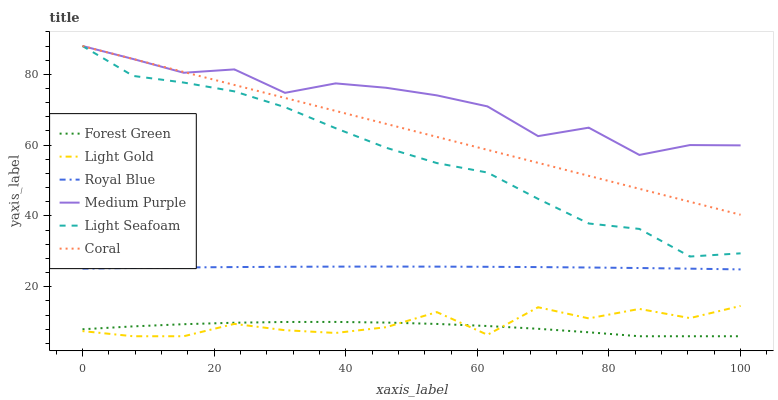Does Forest Green have the minimum area under the curve?
Answer yes or no. Yes. Does Medium Purple have the maximum area under the curve?
Answer yes or no. Yes. Does Royal Blue have the minimum area under the curve?
Answer yes or no. No. Does Royal Blue have the maximum area under the curve?
Answer yes or no. No. Is Coral the smoothest?
Answer yes or no. Yes. Is Light Gold the roughest?
Answer yes or no. Yes. Is Medium Purple the smoothest?
Answer yes or no. No. Is Medium Purple the roughest?
Answer yes or no. No. Does Forest Green have the lowest value?
Answer yes or no. Yes. Does Royal Blue have the lowest value?
Answer yes or no. No. Does Light Seafoam have the highest value?
Answer yes or no. Yes. Does Royal Blue have the highest value?
Answer yes or no. No. Is Light Gold less than Coral?
Answer yes or no. Yes. Is Coral greater than Royal Blue?
Answer yes or no. Yes. Does Light Seafoam intersect Coral?
Answer yes or no. Yes. Is Light Seafoam less than Coral?
Answer yes or no. No. Is Light Seafoam greater than Coral?
Answer yes or no. No. Does Light Gold intersect Coral?
Answer yes or no. No. 